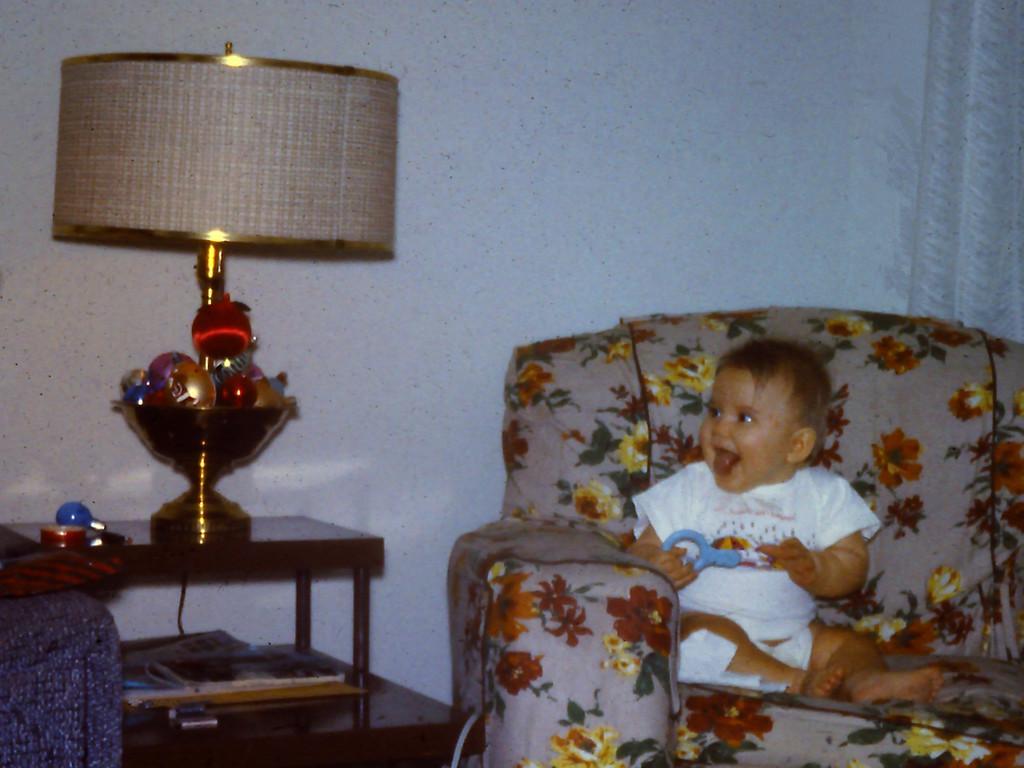Could you give a brief overview of what you see in this image? This picture is clicked the inside the room. On the right bottom of this picture, we see a sofa on which a baby with white T-shirt is sitting on it and is laughing. Beside the baby, we see a table on which lamp is placed and behind that, we see e a wall in white color. 